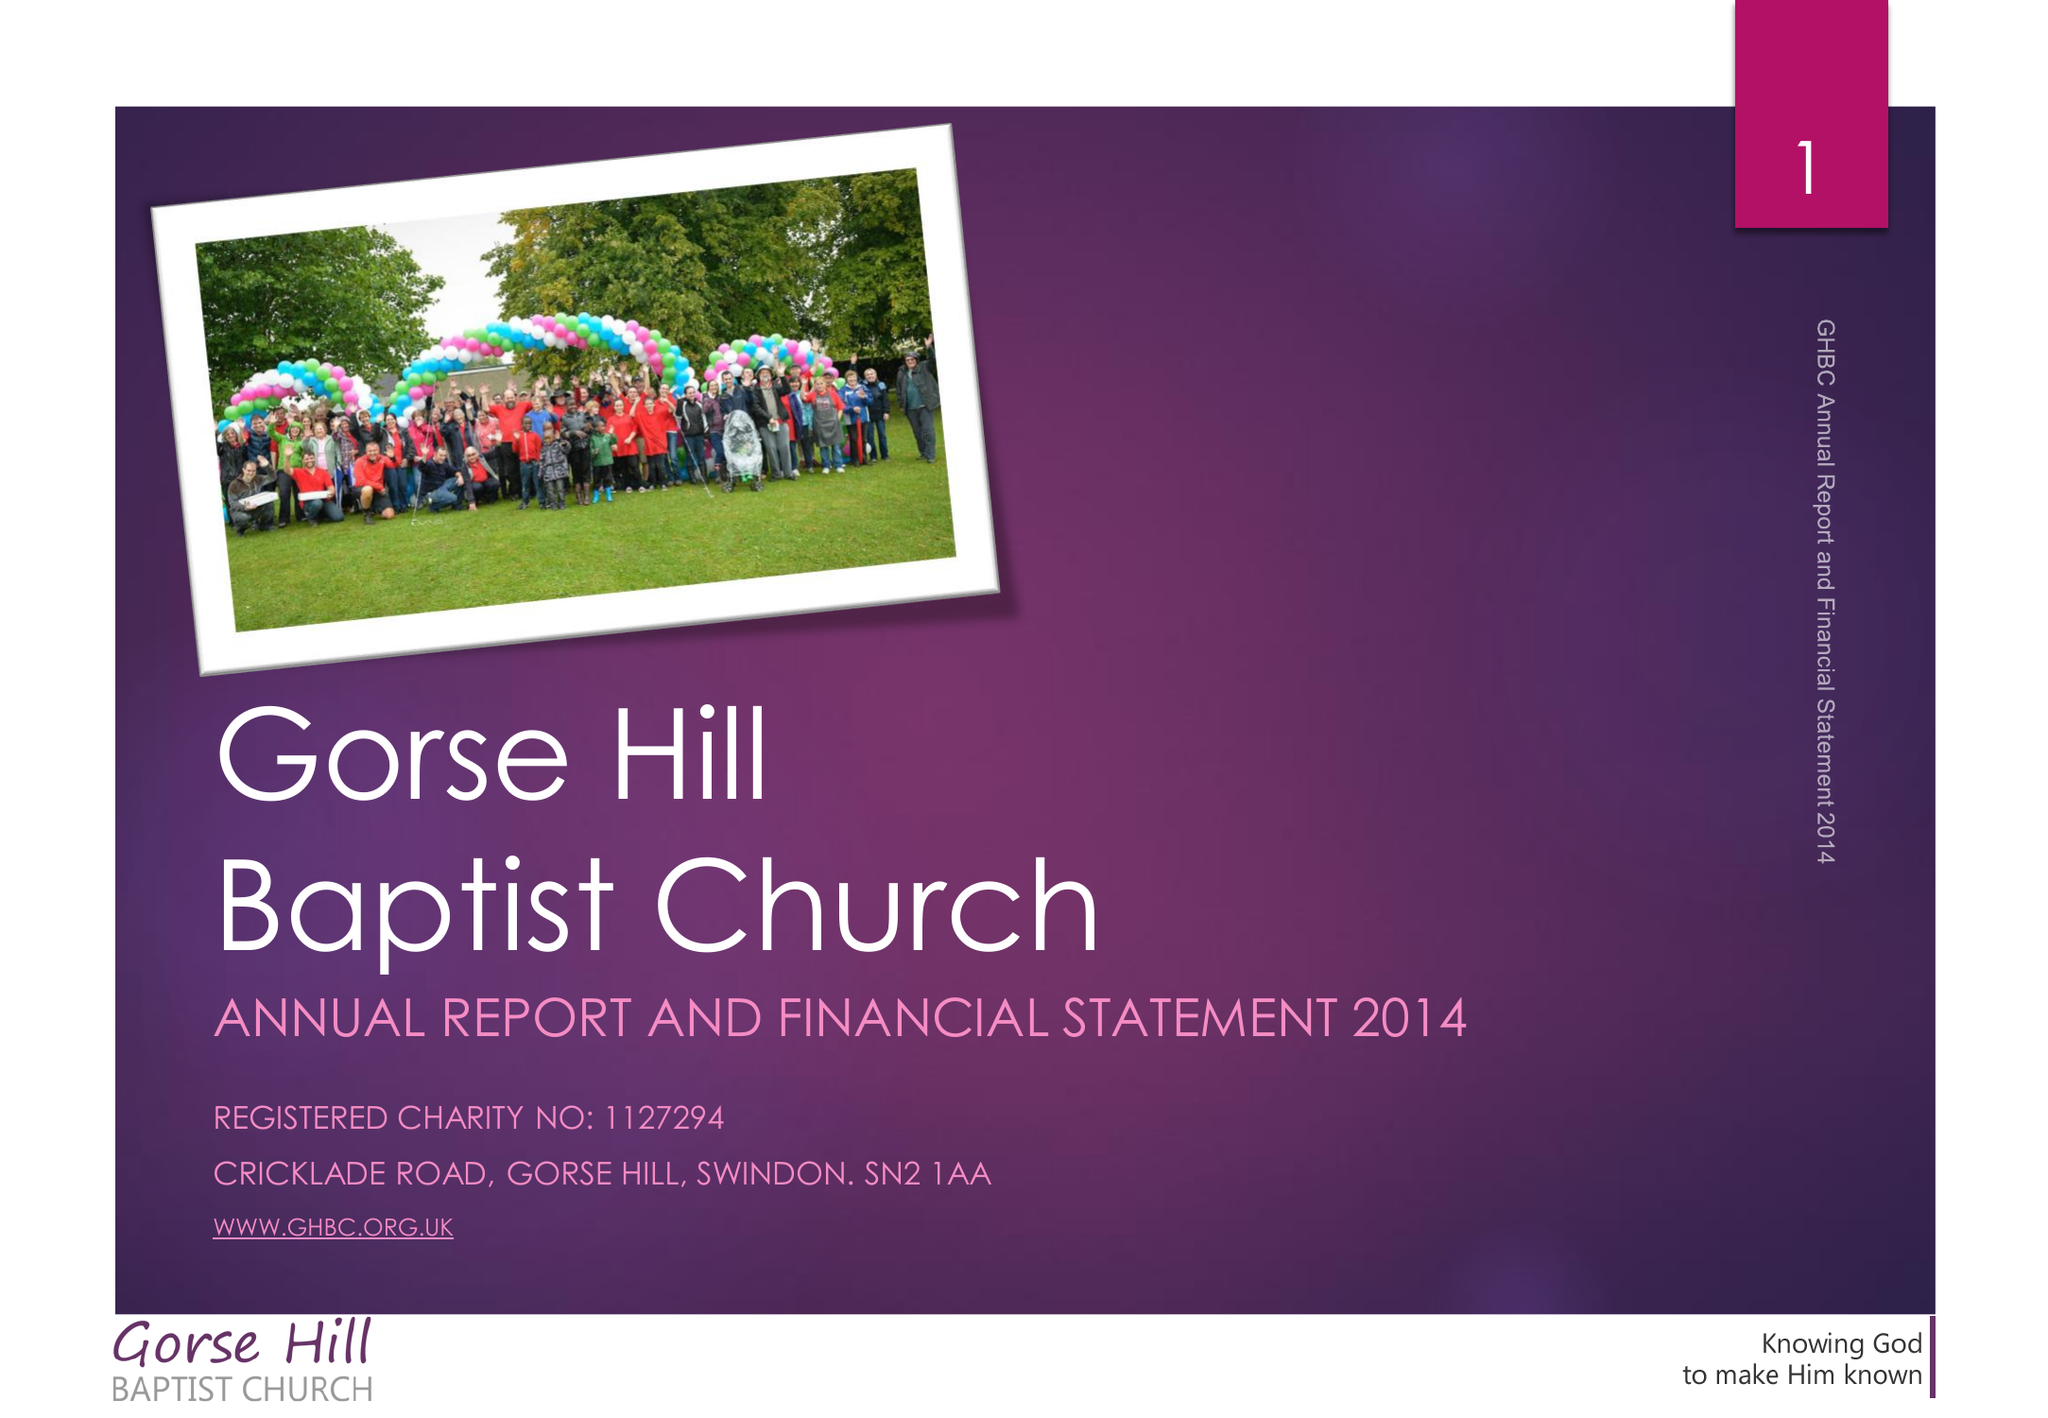What is the value for the address__postcode?
Answer the question using a single word or phrase. SN2 1AA 